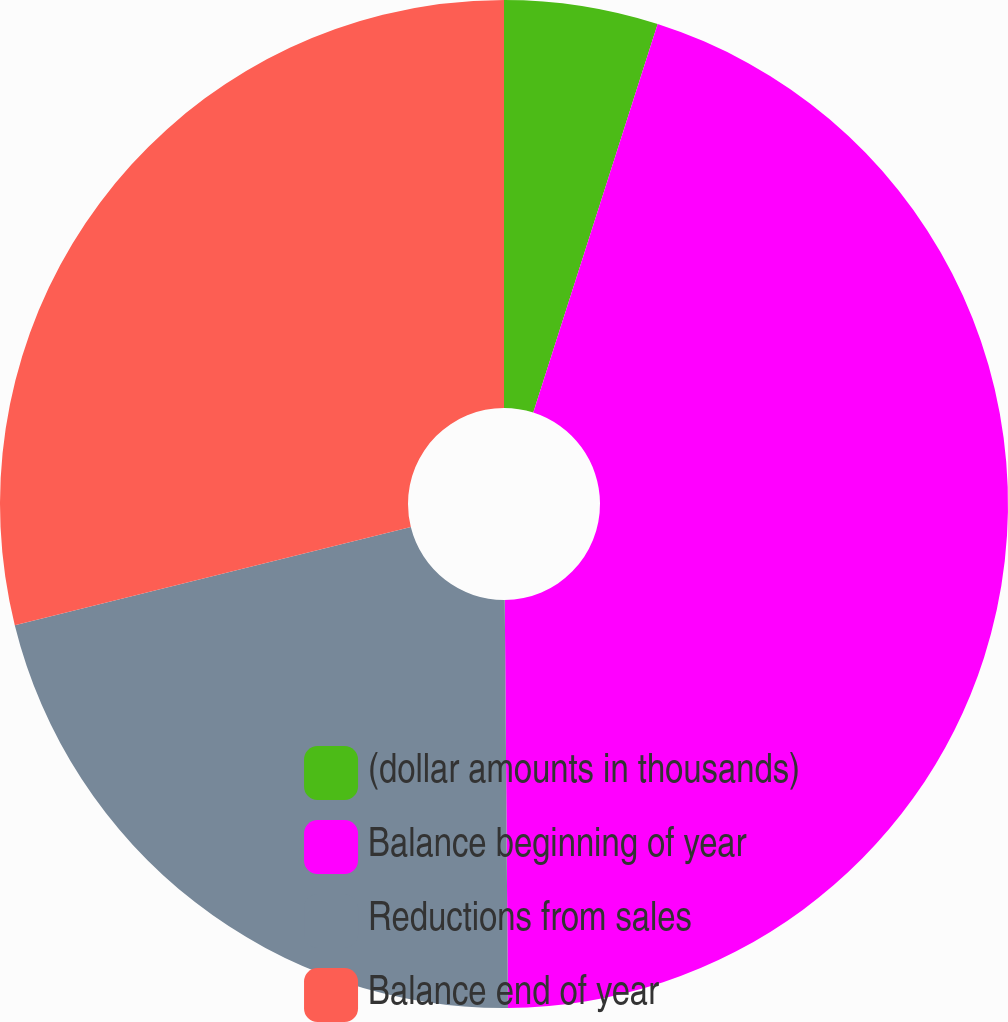<chart> <loc_0><loc_0><loc_500><loc_500><pie_chart><fcel>(dollar amounts in thousands)<fcel>Balance beginning of year<fcel>Reductions from sales<fcel>Balance end of year<nl><fcel>4.93%<fcel>44.94%<fcel>21.26%<fcel>28.86%<nl></chart> 